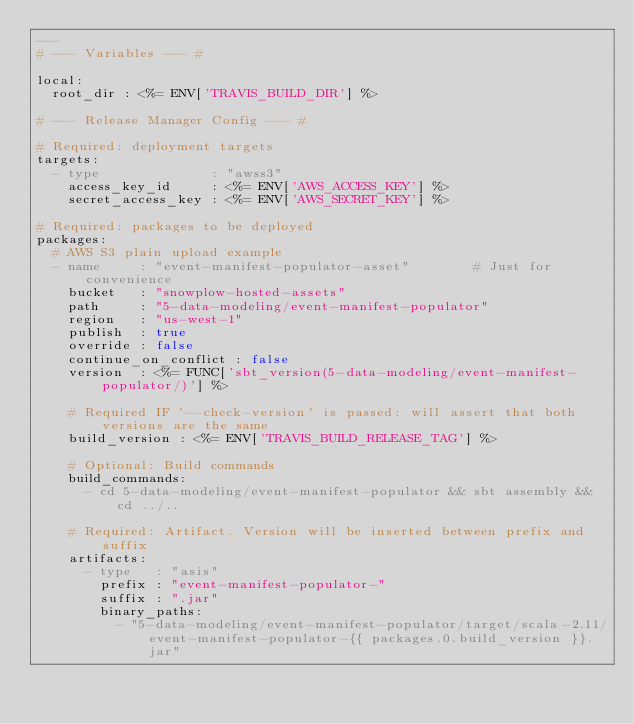Convert code to text. <code><loc_0><loc_0><loc_500><loc_500><_YAML_>---
# --- Variables --- #

local:
  root_dir : <%= ENV['TRAVIS_BUILD_DIR'] %>

# --- Release Manager Config --- #

# Required: deployment targets
targets:
  - type              : "awss3"
    access_key_id     : <%= ENV['AWS_ACCESS_KEY'] %>
    secret_access_key : <%= ENV['AWS_SECRET_KEY'] %>

# Required: packages to be deployed
packages:
  # AWS S3 plain upload example
  - name     : "event-manifest-populator-asset"        # Just for convenience
    bucket   : "snowplow-hosted-assets"
    path     : "5-data-modeling/event-manifest-populator"
    region   : "us-west-1"
    publish  : true
    override : false
    continue_on_conflict : false
    version  : <%= FUNC['sbt_version(5-data-modeling/event-manifest-populator/)'] %>

    # Required IF '--check-version' is passed: will assert that both versions are the same
    build_version : <%= ENV['TRAVIS_BUILD_RELEASE_TAG'] %>

    # Optional: Build commands
    build_commands:
      - cd 5-data-modeling/event-manifest-populator && sbt assembly && cd ../..

    # Required: Artifact. Version will be inserted between prefix and suffix
    artifacts:
      - type   : "asis"
        prefix : "event-manifest-populator-"
        suffix : ".jar"
        binary_paths:
          - "5-data-modeling/event-manifest-populator/target/scala-2.11/event-manifest-populator-{{ packages.0.build_version }}.jar"
</code> 